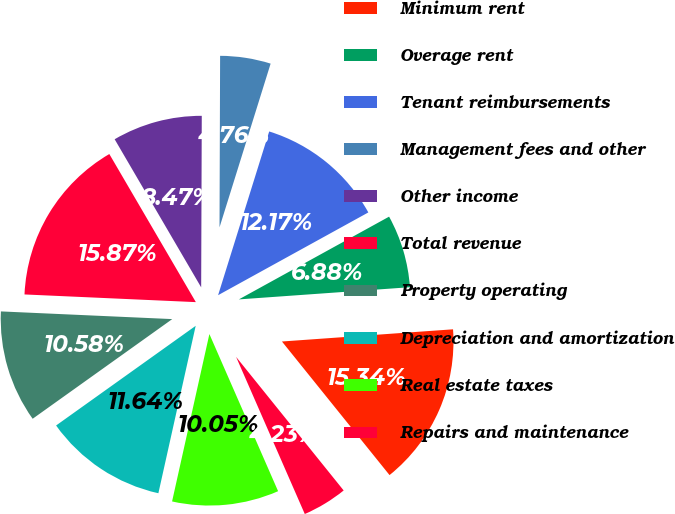<chart> <loc_0><loc_0><loc_500><loc_500><pie_chart><fcel>Minimum rent<fcel>Overage rent<fcel>Tenant reimbursements<fcel>Management fees and other<fcel>Other income<fcel>Total revenue<fcel>Property operating<fcel>Depreciation and amortization<fcel>Real estate taxes<fcel>Repairs and maintenance<nl><fcel>15.34%<fcel>6.88%<fcel>12.17%<fcel>4.76%<fcel>8.47%<fcel>15.87%<fcel>10.58%<fcel>11.64%<fcel>10.05%<fcel>4.23%<nl></chart> 